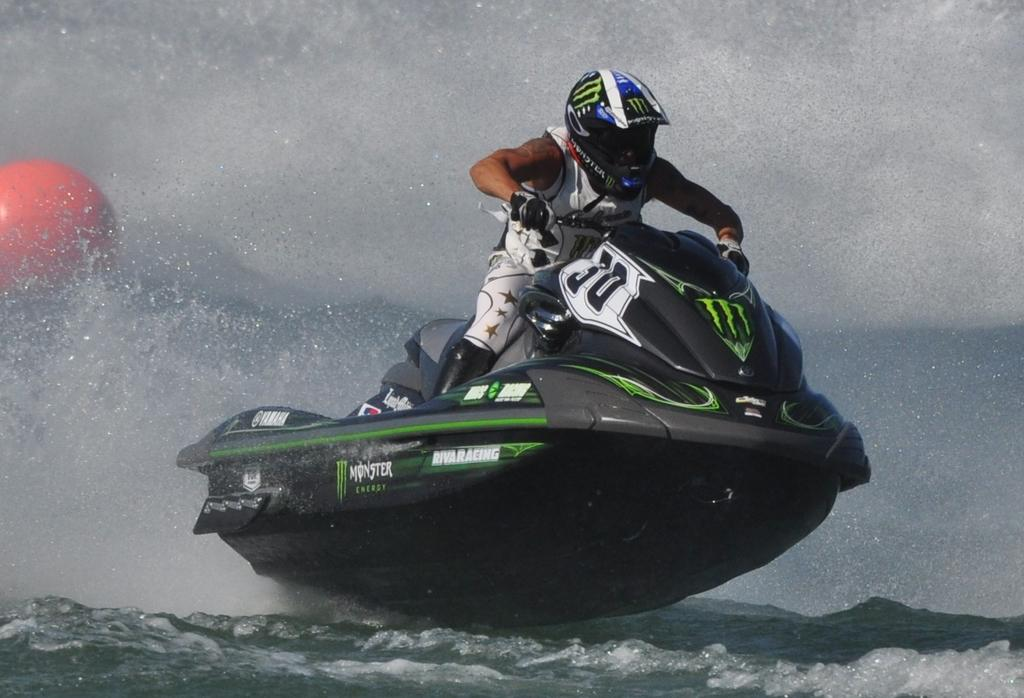Who is the main subject in the image? There is a man in the image. What activity is the man engaged in? The man is doing motor surfing. What is the setting of the image? There is water at the bottom of the image. What can be seen in the background of the image? There is a balloon in the background of the image. What type of soap is being used for the motor surfing in the image? There is no soap present in the image, and motor surfing does not involve the use of soap. 